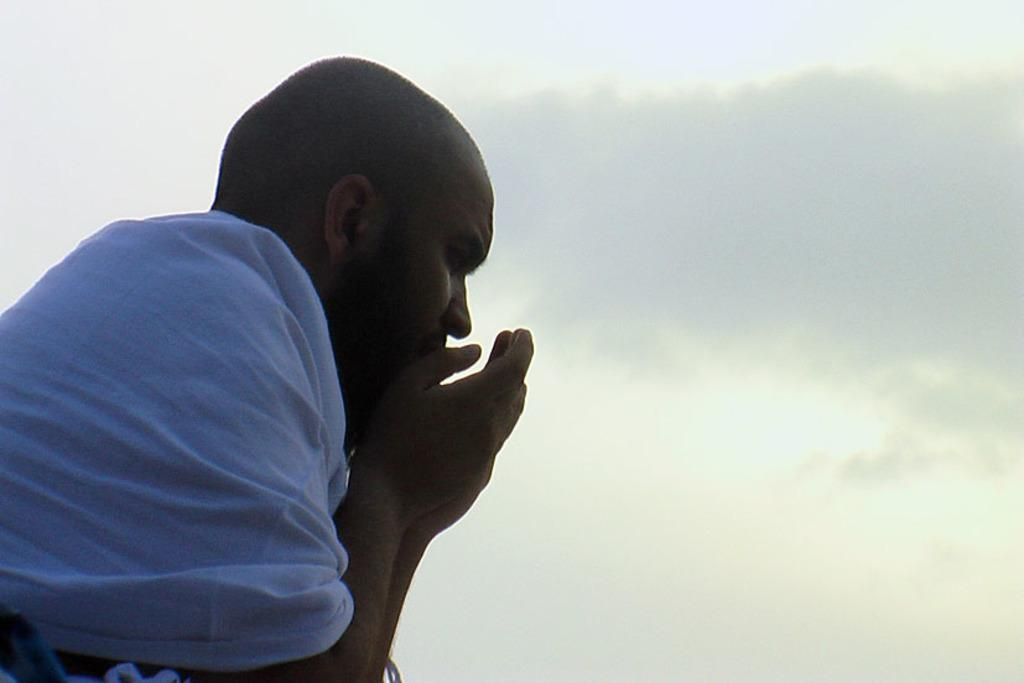Who is on the left side of the image? There is a man on the left side of the image. What can be seen in the background of the image? There are clouds in the sky in the background of the image. What color is the blade in the image? There is no blade present in the image. How many suns are visible in the image? There is no sun visible in the image; only clouds in the sky are present. 